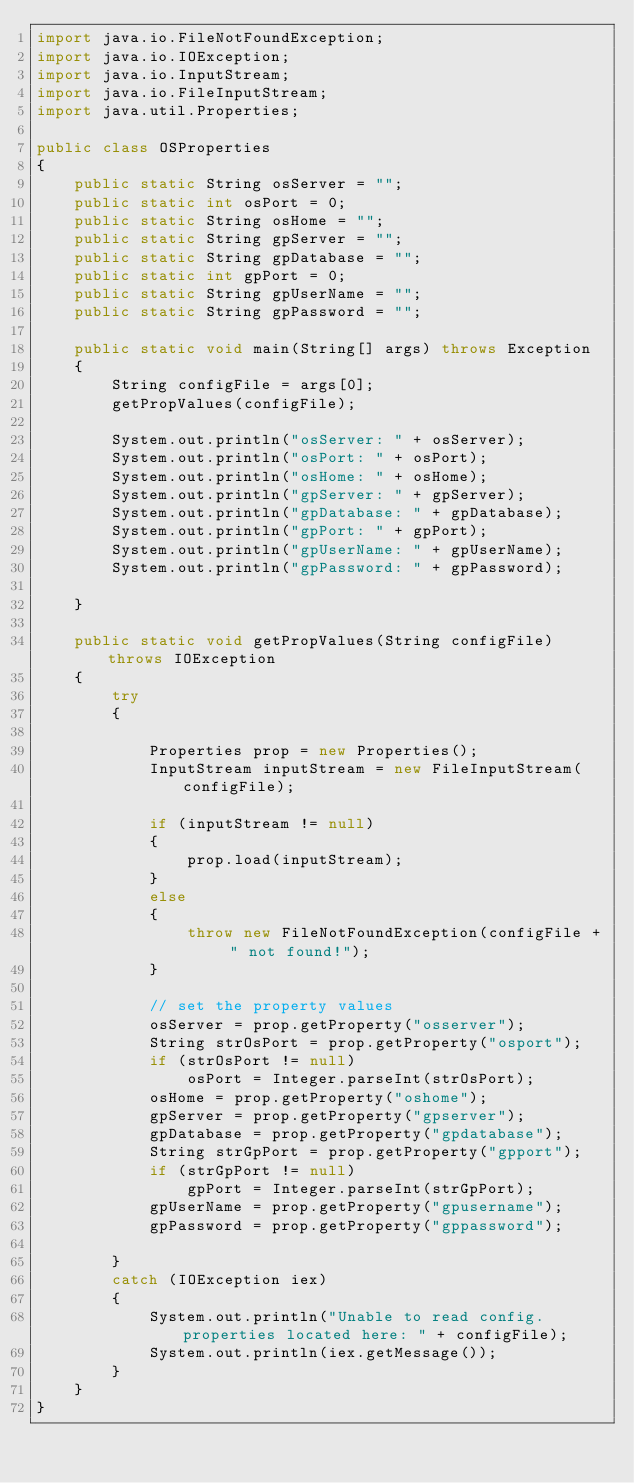Convert code to text. <code><loc_0><loc_0><loc_500><loc_500><_Java_>import java.io.FileNotFoundException;
import java.io.IOException;
import java.io.InputStream;
import java.io.FileInputStream;
import java.util.Properties;

public class OSProperties
{
	public static String osServer = "";
	public static int osPort = 0;
	public static String osHome = "";
	public static String gpServer = "";
	public static String gpDatabase = "";
	public static int gpPort = 0;
	public static String gpUserName = "";
	public static String gpPassword = "";

	public static void main(String[] args) throws Exception
	{
		String configFile = args[0];
		getPropValues(configFile);

		System.out.println("osServer: " + osServer);
		System.out.println("osPort: " + osPort);
		System.out.println("osHome: " + osHome);
		System.out.println("gpServer: " + gpServer);
		System.out.println("gpDatabase: " + gpDatabase);
		System.out.println("gpPort: " + gpPort);
		System.out.println("gpUserName: " + gpUserName);
		System.out.println("gpPassword: " + gpPassword);
		
	} 

	public static void getPropValues(String configFile) throws IOException
	{
		try
		{
 
			Properties prop = new Properties();
			InputStream inputStream = new FileInputStream(configFile);
 
			if (inputStream != null) 
			{
				prop.load(inputStream);
			} 
			else 
			{
				throw new FileNotFoundException(configFile + " not found!");
			}
 
			// set the property values
			osServer = prop.getProperty("osserver");
			String strOsPort = prop.getProperty("osport");
			if (strOsPort != null)
				osPort = Integer.parseInt(strOsPort);
			osHome = prop.getProperty("oshome");
			gpServer = prop.getProperty("gpserver");
			gpDatabase = prop.getProperty("gpdatabase");
			String strGpPort = prop.getProperty("gpport");
			if (strGpPort != null)
				gpPort = Integer.parseInt(strGpPort);
			gpUserName = prop.getProperty("gpusername");
			gpPassword = prop.getProperty("gppassword");

		}
		catch (IOException iex)
		{
			System.out.println("Unable to read config.properties located here: " + configFile);
			System.out.println(iex.getMessage());
		}
	}
}

</code> 